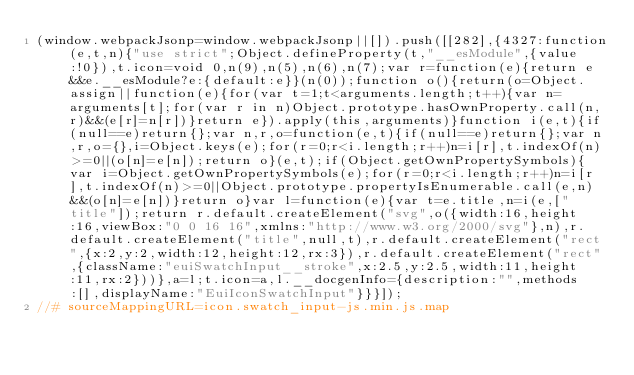Convert code to text. <code><loc_0><loc_0><loc_500><loc_500><_JavaScript_>(window.webpackJsonp=window.webpackJsonp||[]).push([[282],{4327:function(e,t,n){"use strict";Object.defineProperty(t,"__esModule",{value:!0}),t.icon=void 0,n(9),n(5),n(6),n(7);var r=function(e){return e&&e.__esModule?e:{default:e}}(n(0));function o(){return(o=Object.assign||function(e){for(var t=1;t<arguments.length;t++){var n=arguments[t];for(var r in n)Object.prototype.hasOwnProperty.call(n,r)&&(e[r]=n[r])}return e}).apply(this,arguments)}function i(e,t){if(null==e)return{};var n,r,o=function(e,t){if(null==e)return{};var n,r,o={},i=Object.keys(e);for(r=0;r<i.length;r++)n=i[r],t.indexOf(n)>=0||(o[n]=e[n]);return o}(e,t);if(Object.getOwnPropertySymbols){var i=Object.getOwnPropertySymbols(e);for(r=0;r<i.length;r++)n=i[r],t.indexOf(n)>=0||Object.prototype.propertyIsEnumerable.call(e,n)&&(o[n]=e[n])}return o}var l=function(e){var t=e.title,n=i(e,["title"]);return r.default.createElement("svg",o({width:16,height:16,viewBox:"0 0 16 16",xmlns:"http://www.w3.org/2000/svg"},n),r.default.createElement("title",null,t),r.default.createElement("rect",{x:2,y:2,width:12,height:12,rx:3}),r.default.createElement("rect",{className:"euiSwatchInput__stroke",x:2.5,y:2.5,width:11,height:11,rx:2}))},a=l;t.icon=a,l.__docgenInfo={description:"",methods:[],displayName:"EuiIconSwatchInput"}}}]);
//# sourceMappingURL=icon.swatch_input-js.min.js.map</code> 